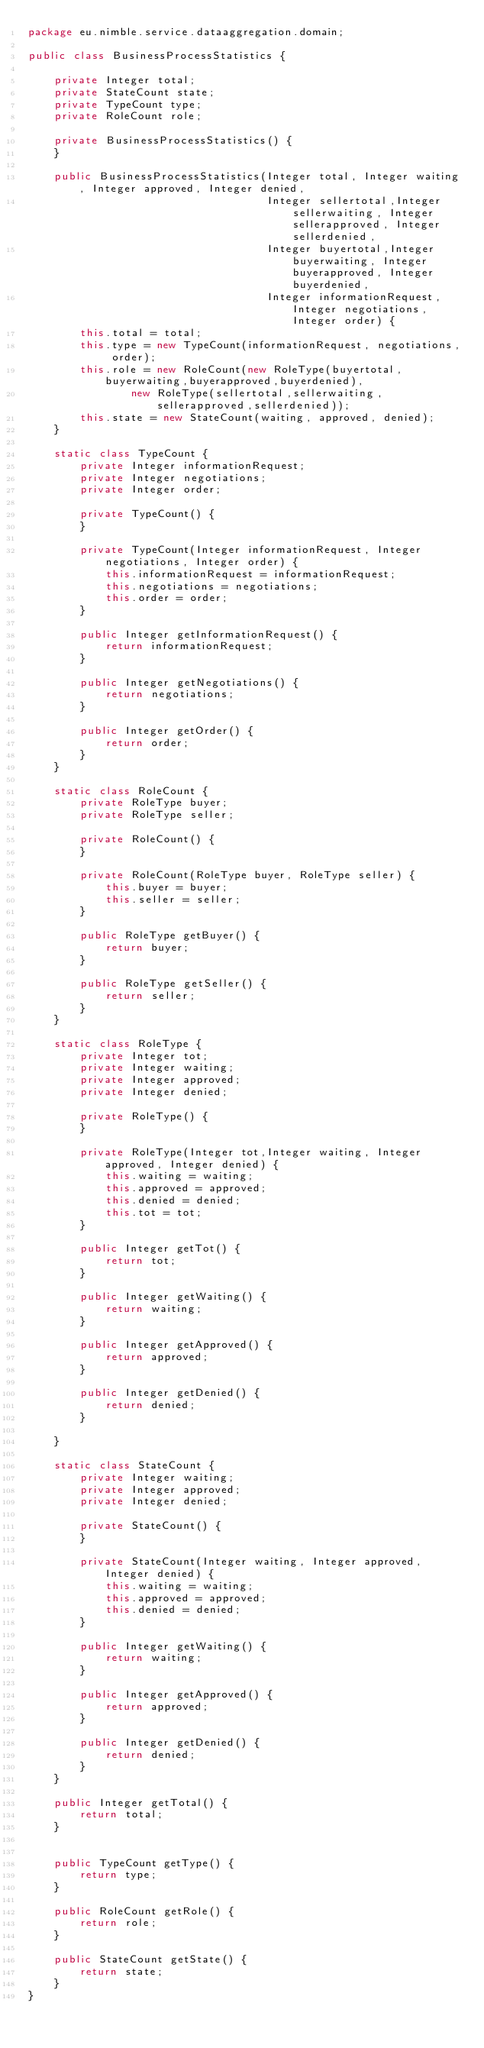<code> <loc_0><loc_0><loc_500><loc_500><_Java_>package eu.nimble.service.dataaggregation.domain;

public class BusinessProcessStatistics {

    private Integer total;
    private StateCount state;
    private TypeCount type;
    private RoleCount role;

    private BusinessProcessStatistics() {
    }

    public BusinessProcessStatistics(Integer total, Integer waiting, Integer approved, Integer denied,
                                     Integer sellertotal,Integer sellerwaiting, Integer sellerapproved, Integer sellerdenied,
                                     Integer buyertotal,Integer buyerwaiting, Integer buyerapproved, Integer buyerdenied,
                                     Integer informationRequest, Integer negotiations, Integer order) {
        this.total = total;
        this.type = new TypeCount(informationRequest, negotiations, order);
        this.role = new RoleCount(new RoleType(buyertotal,buyerwaiting,buyerapproved,buyerdenied),
                new RoleType(sellertotal,sellerwaiting,sellerapproved,sellerdenied));
        this.state = new StateCount(waiting, approved, denied);
    }

    static class TypeCount {
        private Integer informationRequest;
        private Integer negotiations;
        private Integer order;

        private TypeCount() {
        }

        private TypeCount(Integer informationRequest, Integer negotiations, Integer order) {
            this.informationRequest = informationRequest;
            this.negotiations = negotiations;
            this.order = order;
        }

        public Integer getInformationRequest() {
            return informationRequest;
        }

        public Integer getNegotiations() {
            return negotiations;
        }

        public Integer getOrder() {
            return order;
        }
    }

    static class RoleCount {
        private RoleType buyer;
        private RoleType seller;

        private RoleCount() {
        }

        private RoleCount(RoleType buyer, RoleType seller) {
            this.buyer = buyer;
            this.seller = seller;
        }

        public RoleType getBuyer() {
            return buyer;
        }

        public RoleType getSeller() {
            return seller;
        }
    }

    static class RoleType {
        private Integer tot;
        private Integer waiting;
        private Integer approved;
        private Integer denied;

        private RoleType() {
        }

        private RoleType(Integer tot,Integer waiting, Integer approved, Integer denied) {
            this.waiting = waiting;
            this.approved = approved;
            this.denied = denied;
            this.tot = tot;
        }

        public Integer getTot() {
            return tot;
        }

        public Integer getWaiting() {
            return waiting;
        }

        public Integer getApproved() {
            return approved;
        }

        public Integer getDenied() {
            return denied;
        }

    }

    static class StateCount {
        private Integer waiting;
        private Integer approved;
        private Integer denied;

        private StateCount() {
        }

        private StateCount(Integer waiting, Integer approved, Integer denied) {
            this.waiting = waiting;
            this.approved = approved;
            this.denied = denied;
        }

        public Integer getWaiting() {
            return waiting;
        }

        public Integer getApproved() {
            return approved;
        }

        public Integer getDenied() {
            return denied;
        }
    }

    public Integer getTotal() {
        return total;
    }


    public TypeCount getType() {
        return type;
    }

    public RoleCount getRole() {
        return role;
    }

    public StateCount getState() {
        return state;
    }
}
</code> 